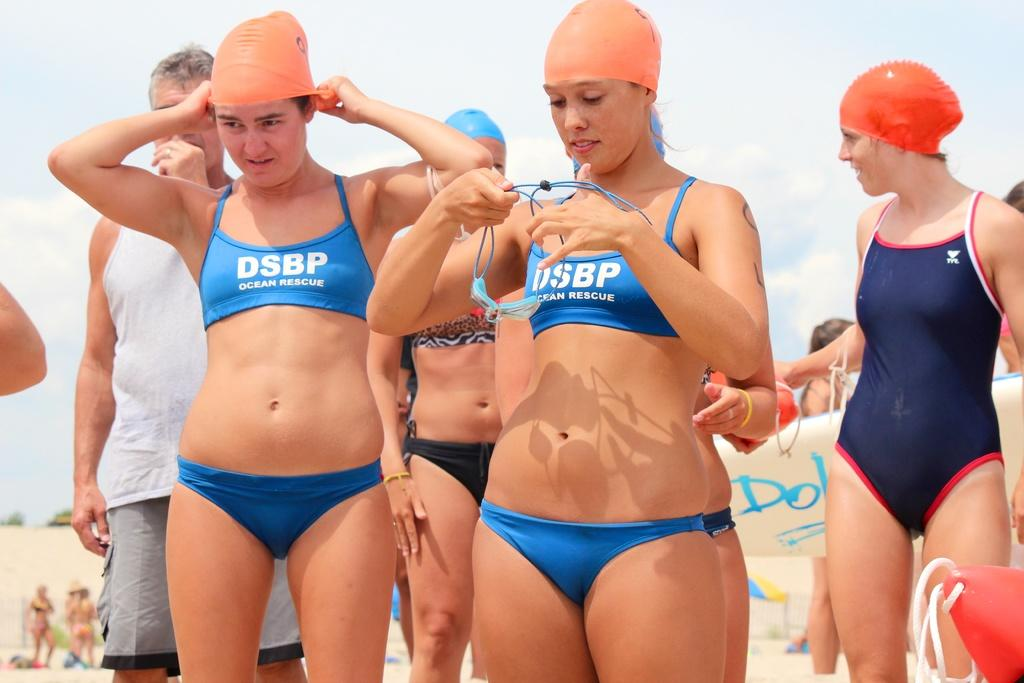How many people are in the image? There are six people in the image, including five women and one man. What are the women wearing in the image? The five women are wearing swimming suits. What is the man wearing in the image? The man is wearing a white and grey dress. What can be seen in the background of the image? The sky is visible in the background of the image. What type of silk fabric is being used to make the bulb in the image? There is no bulb present in the image, and silk fabric is not mentioned in the provided facts. 